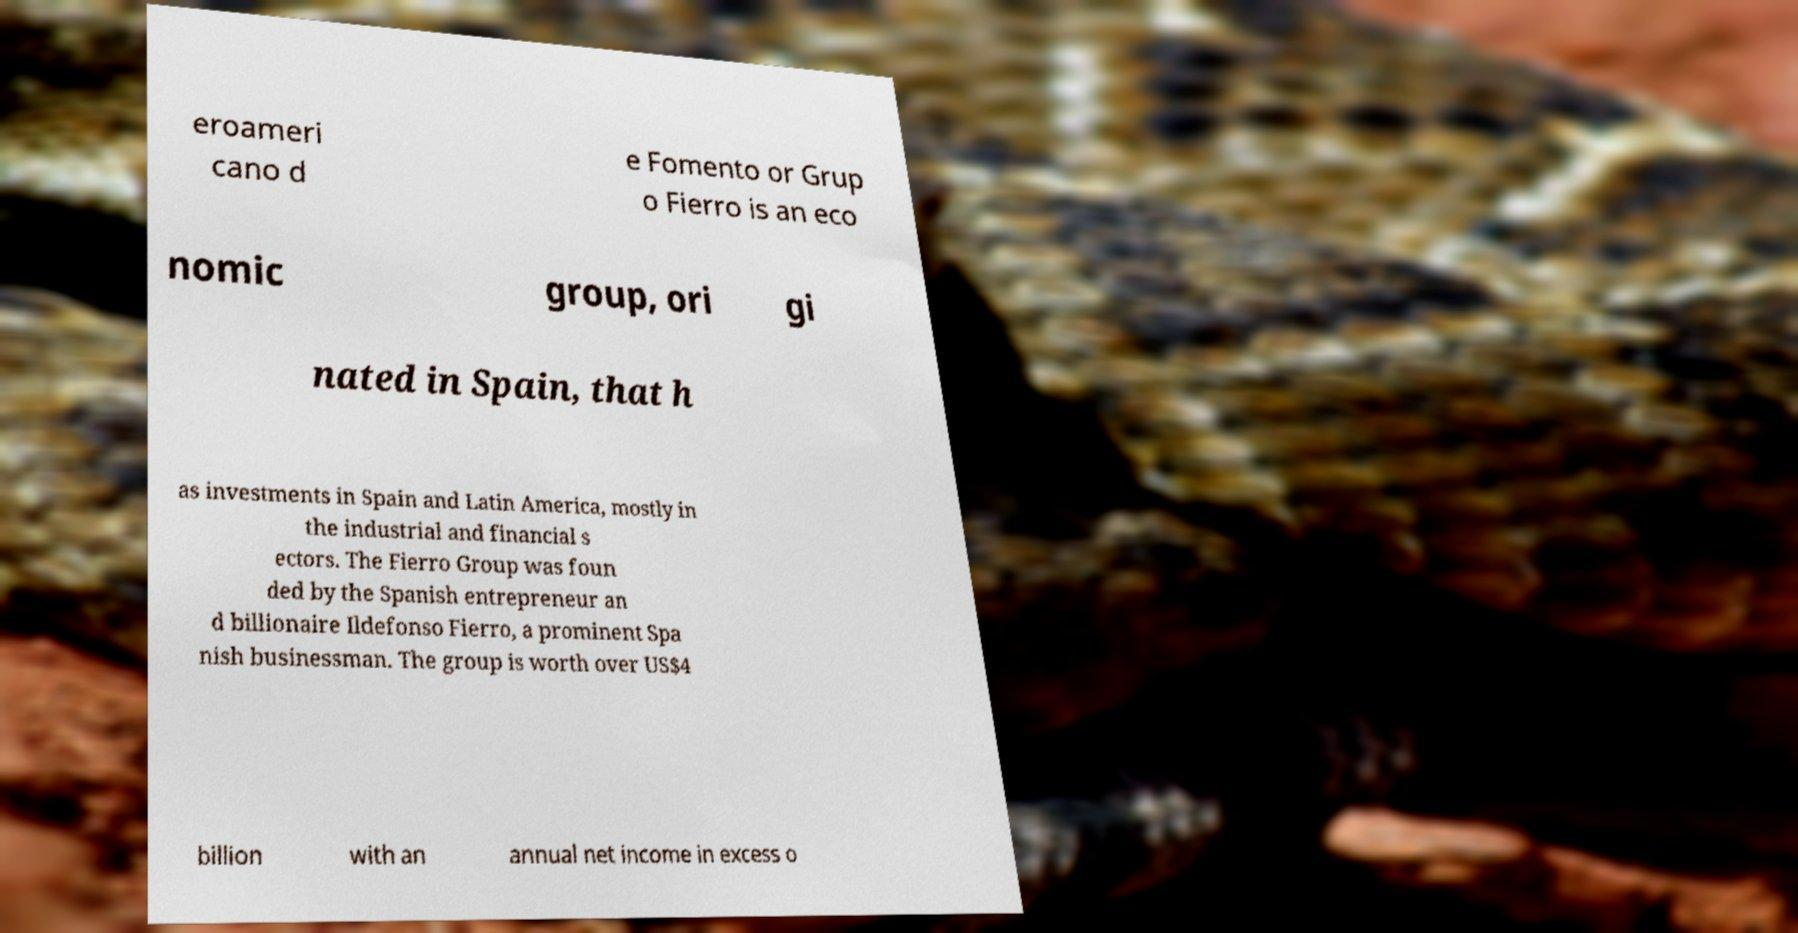I need the written content from this picture converted into text. Can you do that? eroameri cano d e Fomento or Grup o Fierro is an eco nomic group, ori gi nated in Spain, that h as investments in Spain and Latin America, mostly in the industrial and financial s ectors. The Fierro Group was foun ded by the Spanish entrepreneur an d billionaire Ildefonso Fierro, a prominent Spa nish businessman. The group is worth over US$4 billion with an annual net income in excess o 